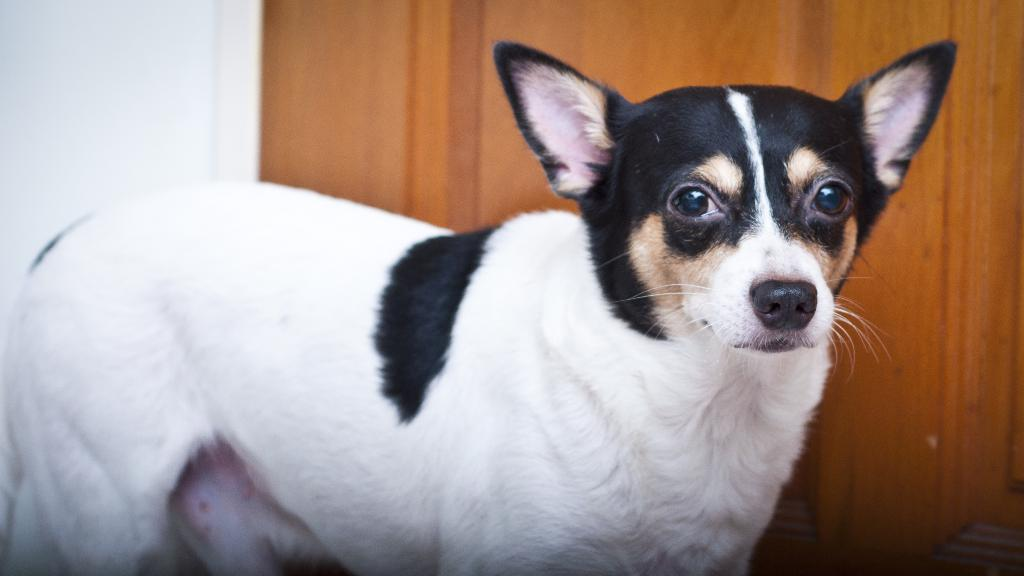What is the main subject in the foreground of the image? There is a dog in the foreground of the image. What can be seen in the background of the image? There is a wall in the background of the image. Can you describe any structures or objects in the image? Yes, there is a wooden door in the image. What type of flag is being waved by the dog in the image? There is no flag present in the image, and the dog is not waving anything. 